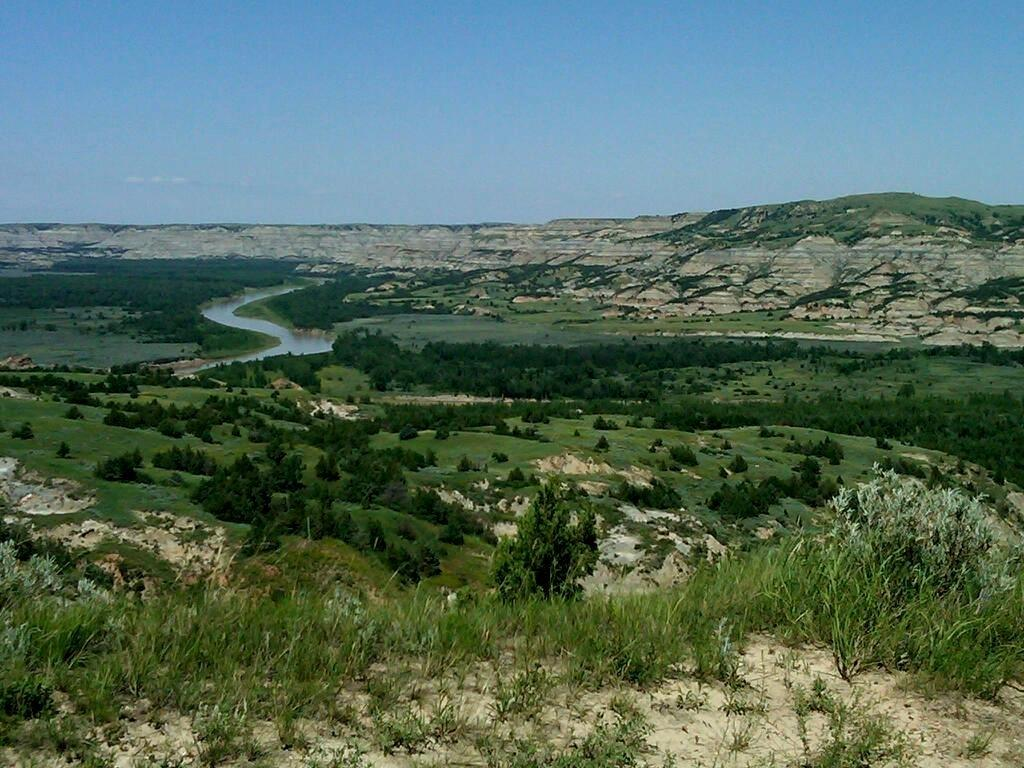What type of vegetation can be seen in the image? There is grass in the image. What other natural elements are present in the image? There are trees and a mountain visible in the image. What can be seen in the water in the image? The water is visible in the image, but it is not clear what is in the water. What is visible in the sky in the image? The sky is visible in the image. What letters are being used to spell out a message in the lunchroom in the image? There is no lunchroom present in the image, and therefore no letters or messages can be observed. 